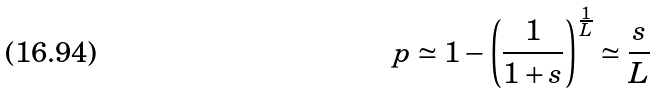Convert formula to latex. <formula><loc_0><loc_0><loc_500><loc_500>p \simeq 1 - \left ( \frac { 1 } { 1 + s } \right ) ^ { \frac { 1 } { L } } \simeq \frac { s } { L }</formula> 